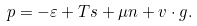<formula> <loc_0><loc_0><loc_500><loc_500>p = - \varepsilon + T s + \mu n + v \cdot g .</formula> 